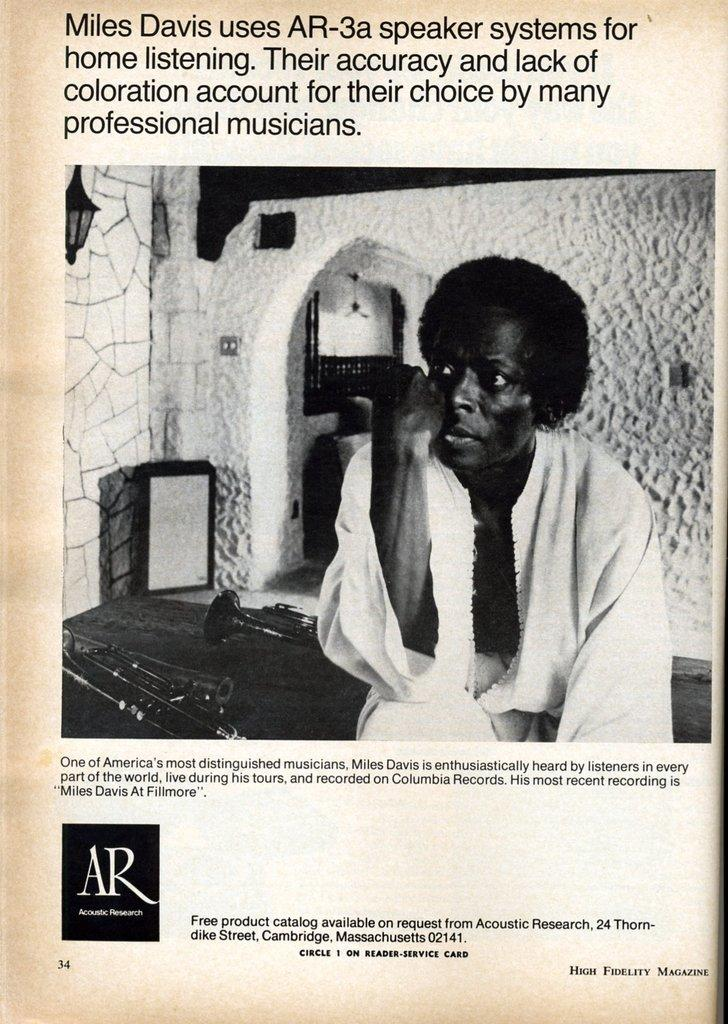What is the main subject of the image? There is a picture of a man in the image. Are there any words or phrases written on the image? Yes, there is text written on the top and bottom sides of the image. Is there any symbol or graphic element in the image? Yes, there is a logo in the left bottom corner of the image. What type of punishment is being depicted in the image? There is no punishment being depicted in the image; it features a picture of a man, text, and a logo. What role does the cannon play in the image? There is no cannon present in the image. 